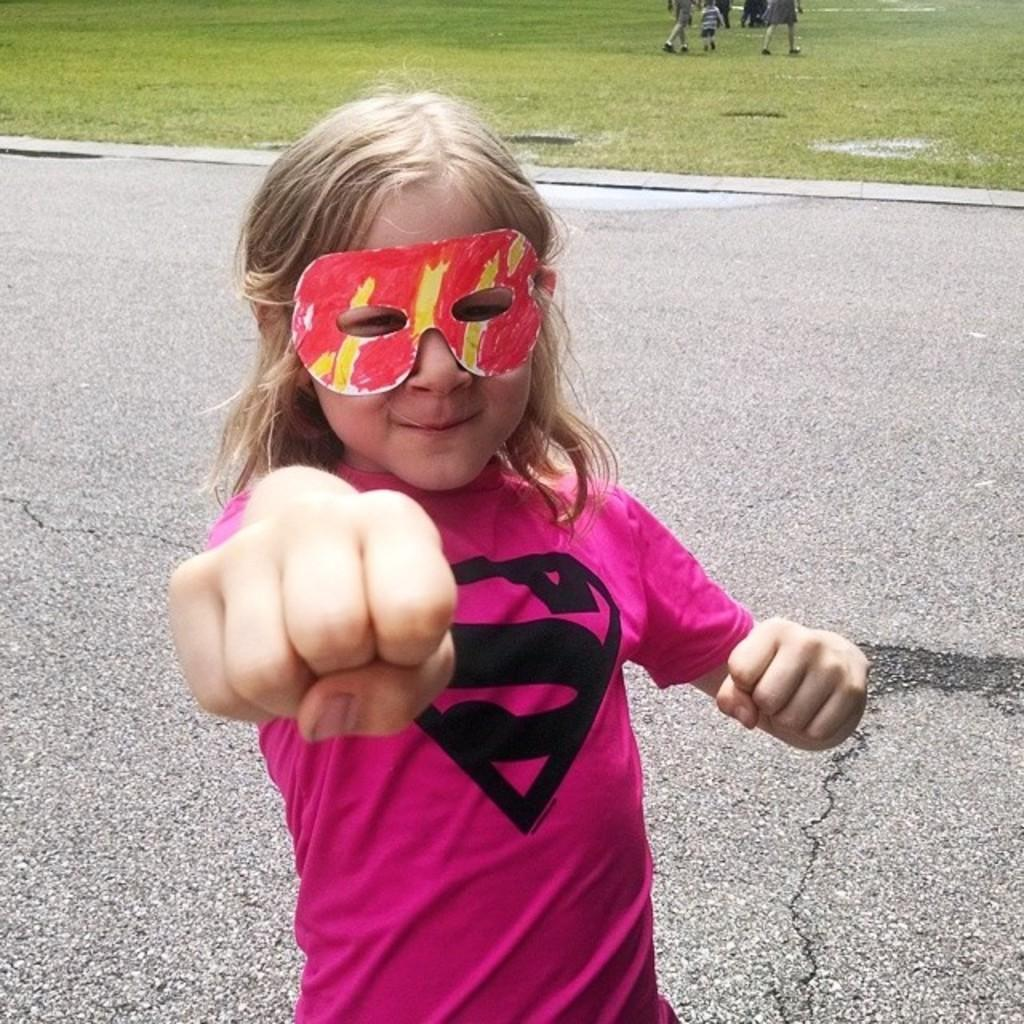Who is the main subject in the image? There is a girl in the image. What is the girl wearing on her face? The girl is wearing a mask. What can be seen in the background of the image? There is a road and grass in the background of the image. Are there any other people visible in the image? Yes, there are people in the background of the image. What type of dinner is the girl preparing in the image? There is no indication in the image that the girl is preparing dinner, as she is wearing a mask and there are no visible cooking utensils or ingredients. --- Facts: 1. There is a car in the image. 2. The car is red. 3. The car has four wheels. 4. There is a road in the image. 5. The road is paved. Absurd Topics: bird, ocean, mountain Conversation: What is the main subject in the image? There is a car in the image. What color is the car? The car is red. How many wheels does the car have? The car has four wheels. What can be seen in the background of the image? There is a road in the image. What type of road is visible in the image? The road is paved. Reasoning: Let's think step by step in order to produce the conversation. We start by identifying the main subject in the image, which is the car. Then, we describe the car's color and the number of wheels it has. Next, we expand the conversation to include the background of the image, mentioning the road. Finally, we provide a detail about the road, stating that it is paved. Absurd Question/Answer: Can you see any mountains in the background of the image? There are no mountains visible in the image; it features a red car and a paved road. 